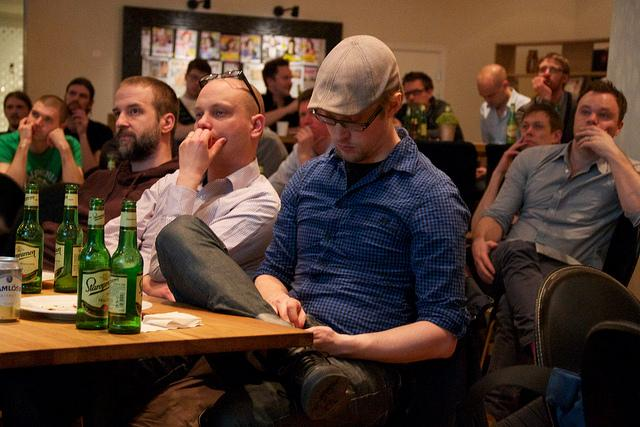How many people in this picture need to see an optometrist regularly? four 